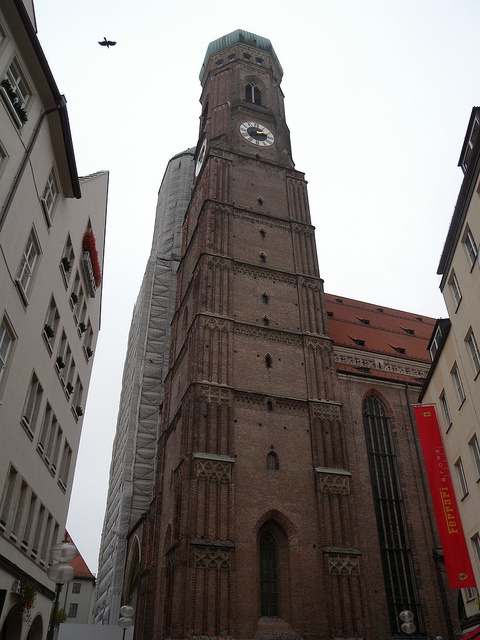Describe the objects in this image and their specific colors. I can see clock in black, gray, and darkgray tones, clock in black, darkgray, gray, and lightgray tones, and bird in black, white, and gray tones in this image. 